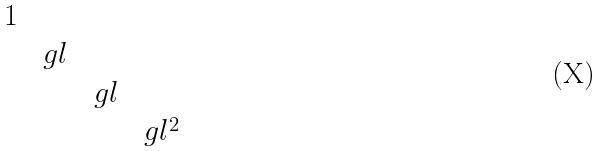Convert formula to latex. <formula><loc_0><loc_0><loc_500><loc_500>\begin{matrix} 1 & & & \\ & \ g l & & \\ & & \ g l & \\ & & & \ g l ^ { 2 } \end{matrix}</formula> 